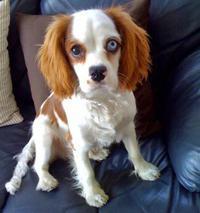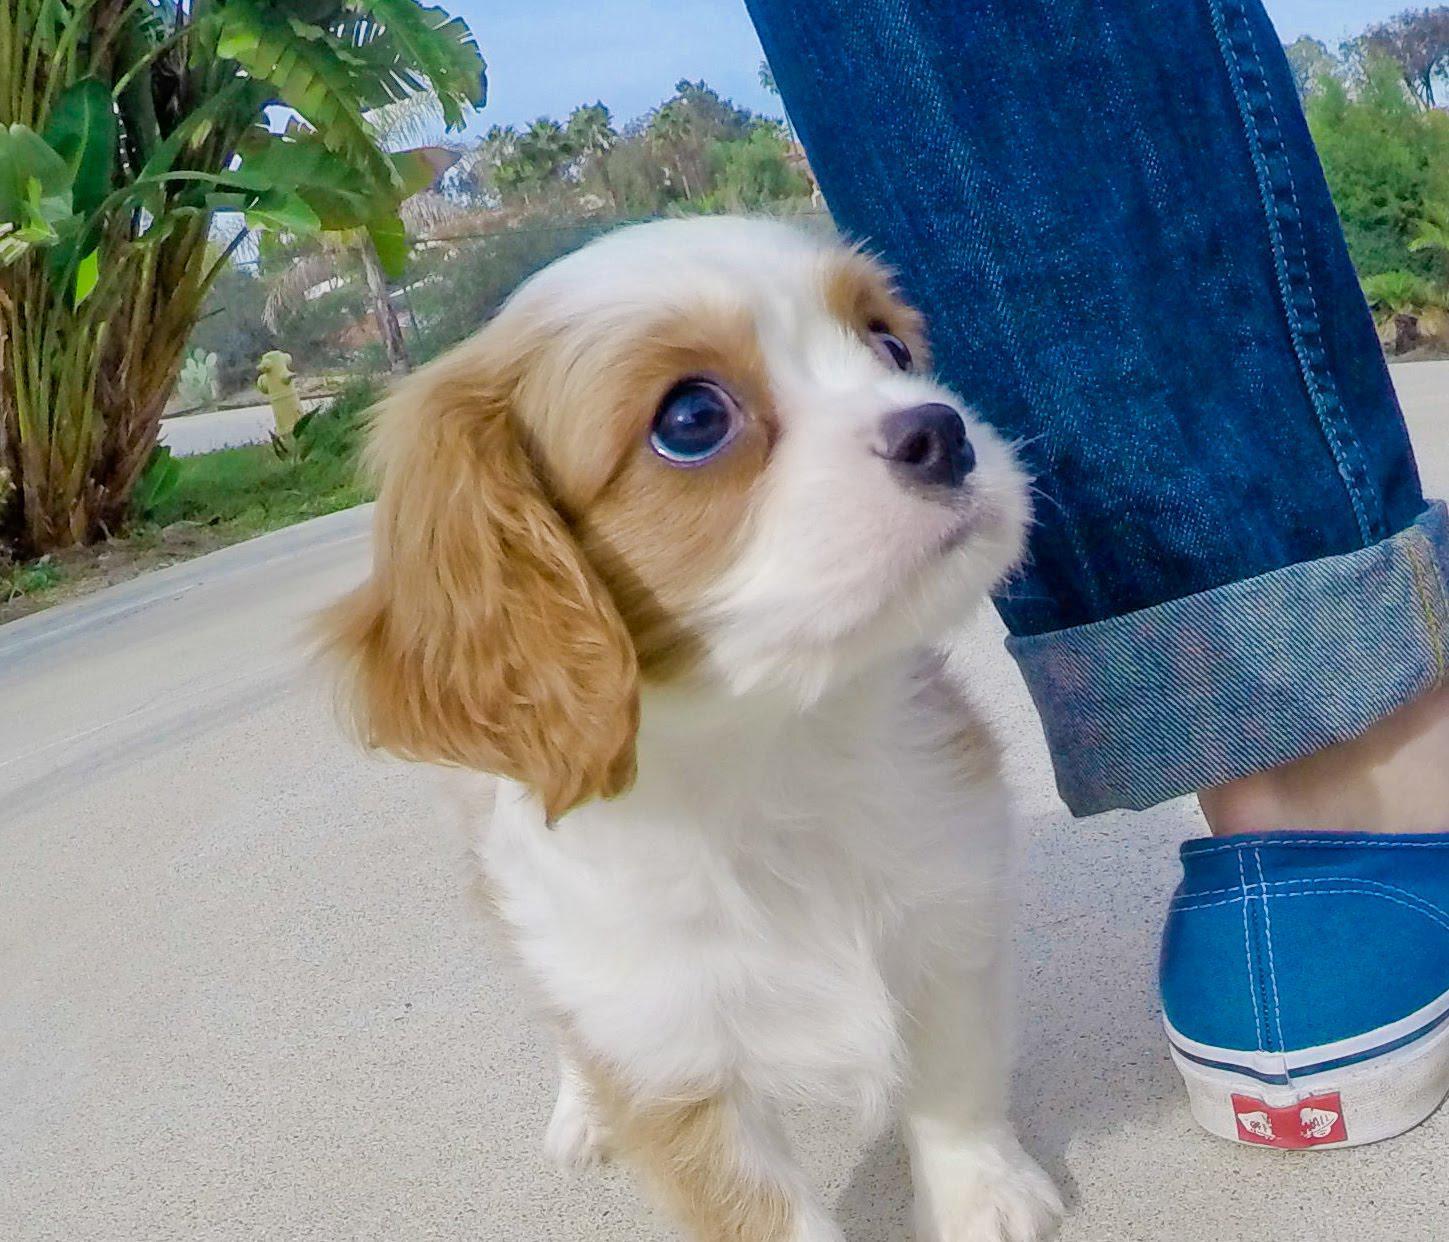The first image is the image on the left, the second image is the image on the right. Assess this claim about the two images: "There is a body part of a human visible in one of the images.". Correct or not? Answer yes or no. Yes. The first image is the image on the left, the second image is the image on the right. Assess this claim about the two images: "A brown-and-white spaniel puppy is held in a human hand outdoors.". Correct or not? Answer yes or no. No. The first image is the image on the left, the second image is the image on the right. For the images shown, is this caption "At least one of the puppies is indoors." true? Answer yes or no. Yes. The first image is the image on the left, the second image is the image on the right. For the images displayed, is the sentence "An image shows one non-standing dog posed in the grass." factually correct? Answer yes or no. No. 